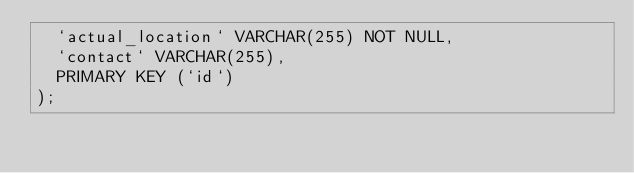Convert code to text. <code><loc_0><loc_0><loc_500><loc_500><_SQL_>	`actual_location` VARCHAR(255) NOT NULL,
	`contact` VARCHAR(255),
	PRIMARY KEY (`id`)
);
</code> 